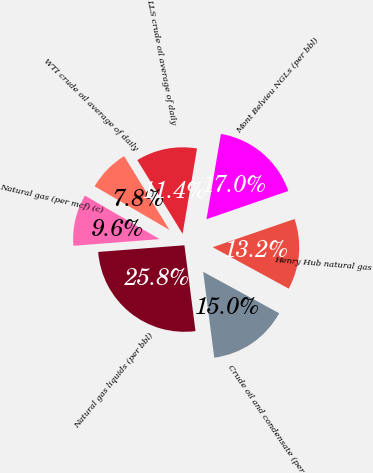<chart> <loc_0><loc_0><loc_500><loc_500><pie_chart><fcel>Crude oil and condensate (per<fcel>Natural gas liquids (per bbl)<fcel>Natural gas (per mcf) (c)<fcel>WTI crude oil average of daily<fcel>LLS crude oil average of daily<fcel>Mont Belvieu NGLs (per bbl)<fcel>Henry Hub natural gas<nl><fcel>15.02%<fcel>25.81%<fcel>9.63%<fcel>7.83%<fcel>11.43%<fcel>17.05%<fcel>13.23%<nl></chart> 